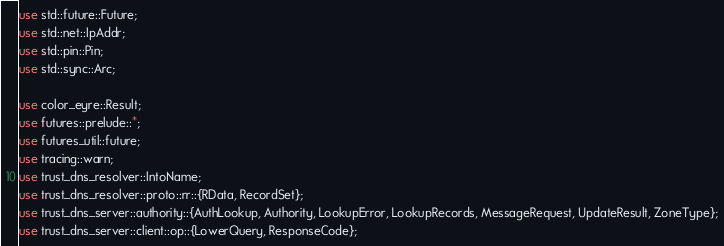Convert code to text. <code><loc_0><loc_0><loc_500><loc_500><_Rust_>use std::future::Future;
use std::net::IpAddr;
use std::pin::Pin;
use std::sync::Arc;

use color_eyre::Result;
use futures::prelude::*;
use futures_util::future;
use tracing::warn;
use trust_dns_resolver::IntoName;
use trust_dns_resolver::proto::rr::{RData, RecordSet};
use trust_dns_server::authority::{AuthLookup, Authority, LookupError, LookupRecords, MessageRequest, UpdateResult, ZoneType};
use trust_dns_server::client::op::{LowerQuery, ResponseCode};</code> 